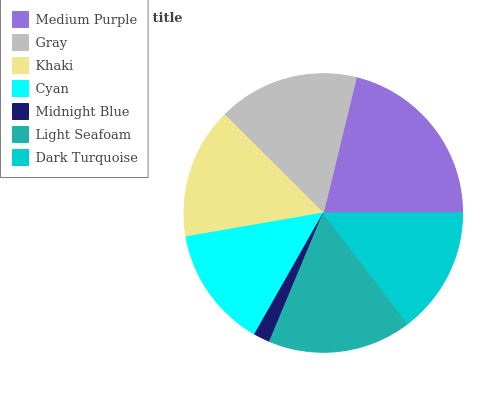Is Midnight Blue the minimum?
Answer yes or no. Yes. Is Medium Purple the maximum?
Answer yes or no. Yes. Is Gray the minimum?
Answer yes or no. No. Is Gray the maximum?
Answer yes or no. No. Is Medium Purple greater than Gray?
Answer yes or no. Yes. Is Gray less than Medium Purple?
Answer yes or no. Yes. Is Gray greater than Medium Purple?
Answer yes or no. No. Is Medium Purple less than Gray?
Answer yes or no. No. Is Khaki the high median?
Answer yes or no. Yes. Is Khaki the low median?
Answer yes or no. Yes. Is Cyan the high median?
Answer yes or no. No. Is Gray the low median?
Answer yes or no. No. 